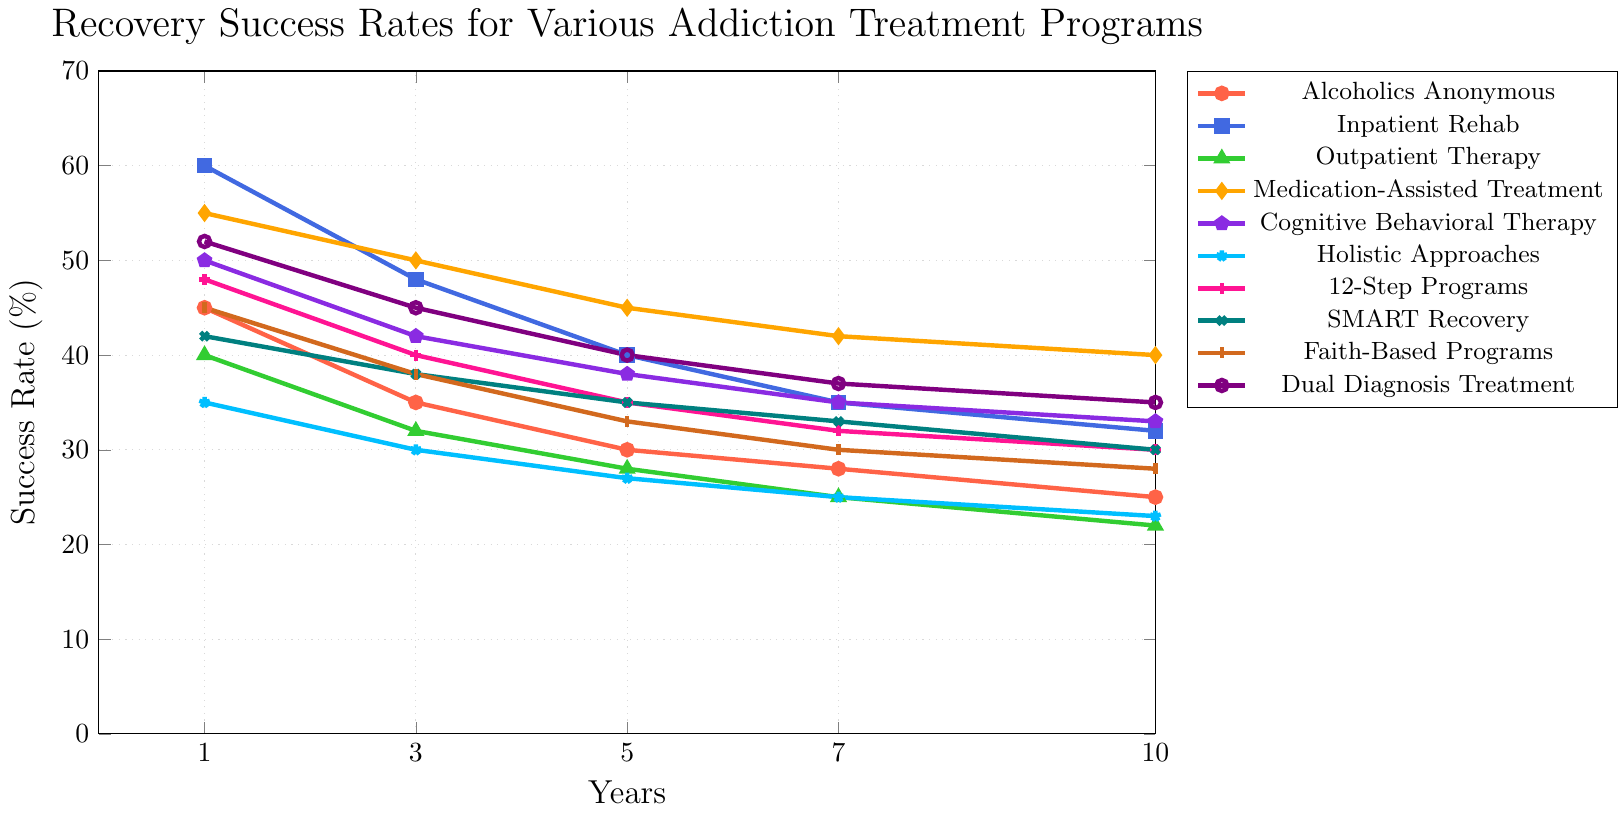What's the recovery success rate of Inpatient Rehab after 3 years? Look for the point in the 'Inpatient Rehab' line corresponding to the X-axis value of 3 years. The success rate for this point is 48%.
Answer: 48% Which program has the highest recovery success rate at the 1-year mark? Compare the Y-axis value of all the programs at the 1-year mark. The program with the highest success rate is Inpatient Rehab with a value of 60%.
Answer: Inpatient Rehab What is the difference in recovery success rates between Alcoholics Anonymous and Cognitive Behavioral Therapy at the 5-year mark? At the 5-year mark, find the recovery rates for both programs: Alcoholics Anonymous is 30% and Cognitive Behavioral Therapy is 38%. The difference is 38% - 30% = 8%.
Answer: 8% On average, what is the recovery success rate of Holistic Approaches over the 10-year period? Sum up the recovery rates for Holistic Approaches at 1, 3, 5, 7, and 10 years: 35 + 30 + 27 + 25 + 23 = 140. Then, divide by 5: 140 / 5 = 28%.
Answer: 28% Is the success rate of Medication-Assisted Treatment consistently higher than Faith-Based Programs over the entire period? For each time point (1, 3, 5, 7, and 10 years), compare the recovery rates of Medication-Assisted Treatment to those of Faith-Based Programs. For all time points, Medication-Assisted Treatment has higher rates (55, 50, 45, 42, 40 vs 45, 38, 33, 30, 28).
Answer: Yes Which program shows the greatest decline in success rate from the 1-year mark to the 10-year mark? Calculate the decline for each program from 1 year to 10 years by subtracting the 10-year rate from the 1-year rate. The program with the greatest decline is 'Inpatient Rehab' with a drop of 60 - 32 = 28%.
Answer: Inpatient Rehab How does the 7-year recovery rate for Dual Diagnosis Treatment compare to that for SMART Recovery? Find the Y-axis value for both Dual Diagnosis Treatment and SMART Recovery at the 7-year mark. Dual Diagnosis Treatment has a rate of 37% and SMART Recovery is at 33%. 37% is greater than 33%.
Answer: Dual Diagnosis Treatment > SMART Recovery What color represents the Alcoholics Anonymous line on the chart? Observe the line corresponding to Alcoholics Anonymous in the legend. The line for Alcoholics Anonymous is depicted in red.
Answer: Red Calculate the average recovery success rate at the 7-year mark for all programs. Sum the recovery rates for all programs at the 7-year mark: 28 + 35 + 25 + 42 + 35 + 25 + 32 + 33 + 30 + 37 = 322. Then, divide by the number of programs (10): 322 / 10 = 32.2%.
Answer: 32.2% What is the overall trend in recovery success rates for Medication-Assisted Treatment from 1 year to 10 years? Follow the Medication-Assisted Treatment line from the 1-year mark to the 10-year mark. The rate decreases from 55% to 40%, showing a steady decline over time.
Answer: Steady decline 